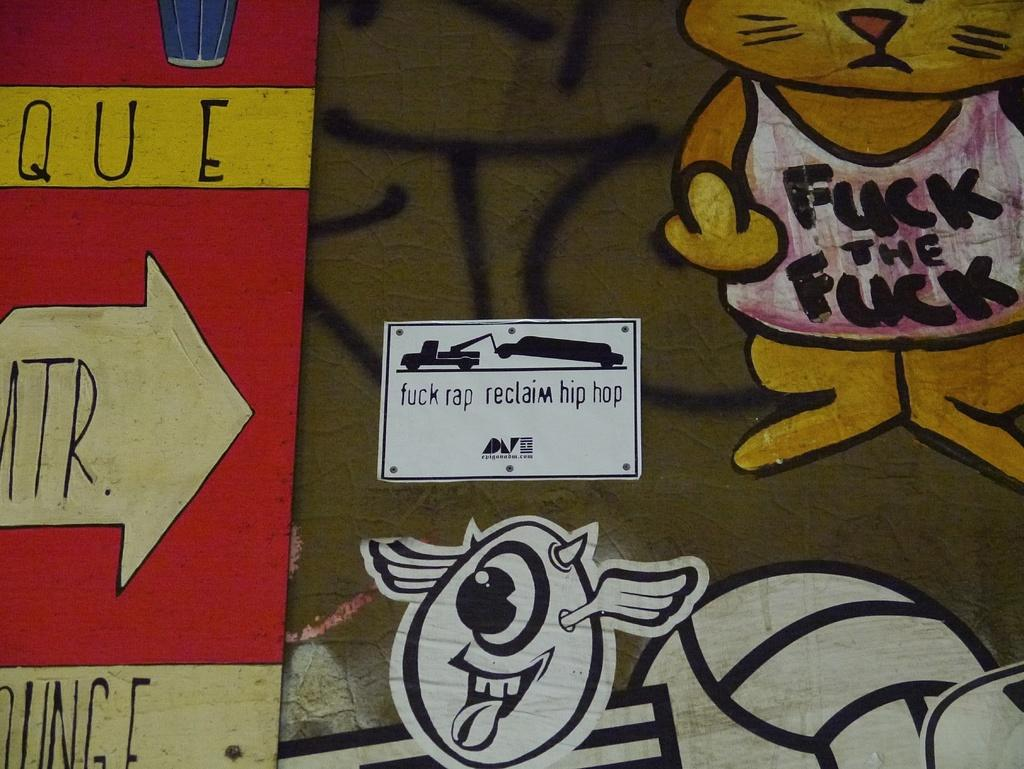What objects are present in the image? There are boards and paintings in the image. Where are the boards and paintings located? The boards and paintings are on a platform. What type of chin can be seen on the paintings in the image? There are no chins present in the image, as the paintings are not of people or animals. 